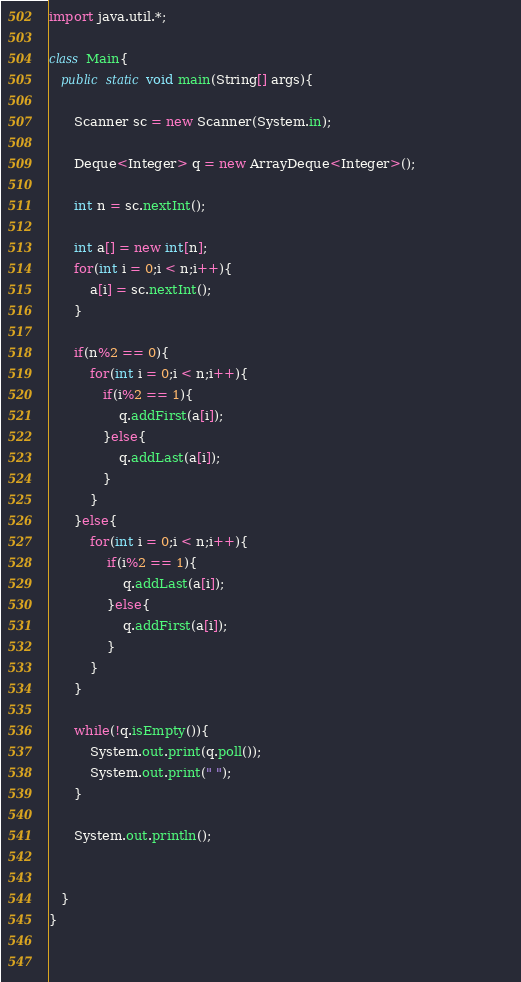Convert code to text. <code><loc_0><loc_0><loc_500><loc_500><_Java_>import java.util.*;

class Main{       
   public static void main(String[] args){
     
      Scanner sc = new Scanner(System.in);                                            
  
      Deque<Integer> q = new ArrayDeque<Integer>();
      
      int n = sc.nextInt();
      
      int a[] = new int[n];
      for(int i = 0;i < n;i++){
          a[i] = sc.nextInt();
      }
      
      if(n%2 == 0){
          for(int i = 0;i < n;i++){
             if(i%2 == 1){
                 q.addFirst(a[i]);
             }else{
                 q.addLast(a[i]);
             }
          }          
      }else{
          for(int i = 0;i < n;i++){
              if(i%2 == 1){
                  q.addLast(a[i]);
              }else{
                  q.addFirst(a[i]);
              }
          }
      }
      
      while(!q.isEmpty()){
          System.out.print(q.poll());
          System.out.print(" ");
      }
     
      System.out.println();
       
      
   }
}
        
        
</code> 